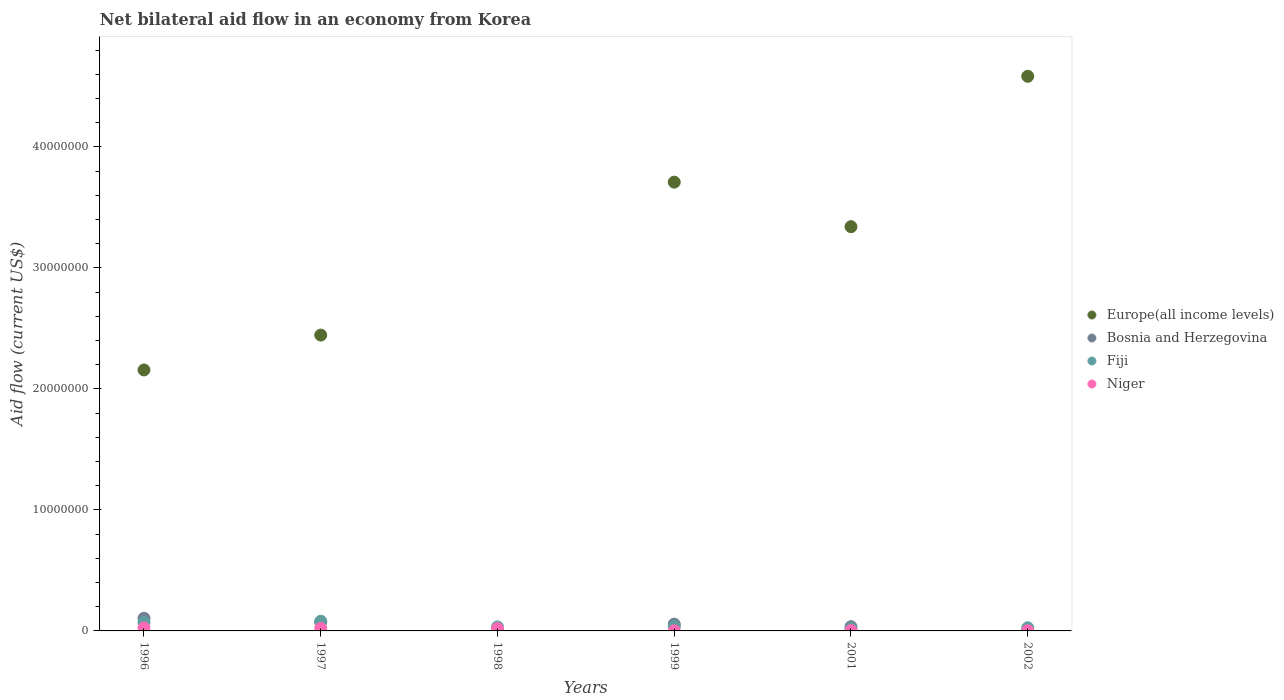What is the net bilateral aid flow in Fiji in 1998?
Provide a short and direct response. 3.30e+05. Across all years, what is the minimum net bilateral aid flow in Bosnia and Herzegovina?
Ensure brevity in your answer.  10000. What is the total net bilateral aid flow in Europe(all income levels) in the graph?
Provide a succinct answer. 1.62e+08. What is the difference between the net bilateral aid flow in Niger in 1998 and the net bilateral aid flow in Bosnia and Herzegovina in 2001?
Offer a terse response. -1.60e+05. In the year 1996, what is the difference between the net bilateral aid flow in Europe(all income levels) and net bilateral aid flow in Bosnia and Herzegovina?
Your answer should be compact. 2.05e+07. What is the ratio of the net bilateral aid flow in Niger in 1996 to that in 1999?
Keep it short and to the point. 24. What is the difference between the highest and the second highest net bilateral aid flow in Europe(all income levels)?
Ensure brevity in your answer.  8.75e+06. What is the difference between the highest and the lowest net bilateral aid flow in Bosnia and Herzegovina?
Offer a terse response. 1.03e+06. Does the net bilateral aid flow in Bosnia and Herzegovina monotonically increase over the years?
Your answer should be compact. No. Is the net bilateral aid flow in Europe(all income levels) strictly less than the net bilateral aid flow in Fiji over the years?
Your answer should be very brief. No. How many years are there in the graph?
Your response must be concise. 6. Where does the legend appear in the graph?
Your answer should be very brief. Center right. How many legend labels are there?
Provide a succinct answer. 4. What is the title of the graph?
Offer a terse response. Net bilateral aid flow in an economy from Korea. What is the label or title of the X-axis?
Give a very brief answer. Years. What is the Aid flow (current US$) of Europe(all income levels) in 1996?
Offer a terse response. 2.16e+07. What is the Aid flow (current US$) in Bosnia and Herzegovina in 1996?
Offer a terse response. 1.04e+06. What is the Aid flow (current US$) of Fiji in 1996?
Offer a terse response. 7.10e+05. What is the Aid flow (current US$) in Niger in 1996?
Make the answer very short. 2.40e+05. What is the Aid flow (current US$) of Europe(all income levels) in 1997?
Keep it short and to the point. 2.44e+07. What is the Aid flow (current US$) of Bosnia and Herzegovina in 1997?
Your response must be concise. 7.20e+05. What is the Aid flow (current US$) in Europe(all income levels) in 1999?
Offer a terse response. 3.71e+07. What is the Aid flow (current US$) of Bosnia and Herzegovina in 1999?
Your response must be concise. 5.60e+05. What is the Aid flow (current US$) in Europe(all income levels) in 2001?
Provide a succinct answer. 3.34e+07. What is the Aid flow (current US$) of Bosnia and Herzegovina in 2001?
Your response must be concise. 3.50e+05. What is the Aid flow (current US$) of Europe(all income levels) in 2002?
Ensure brevity in your answer.  4.58e+07. What is the Aid flow (current US$) in Fiji in 2002?
Offer a terse response. 2.60e+05. Across all years, what is the maximum Aid flow (current US$) of Europe(all income levels)?
Your answer should be compact. 4.58e+07. Across all years, what is the maximum Aid flow (current US$) in Bosnia and Herzegovina?
Provide a short and direct response. 1.04e+06. Across all years, what is the minimum Aid flow (current US$) of Europe(all income levels)?
Make the answer very short. 0. Across all years, what is the minimum Aid flow (current US$) in Bosnia and Herzegovina?
Keep it short and to the point. 10000. Across all years, what is the minimum Aid flow (current US$) in Fiji?
Give a very brief answer. 1.80e+05. What is the total Aid flow (current US$) in Europe(all income levels) in the graph?
Ensure brevity in your answer.  1.62e+08. What is the total Aid flow (current US$) of Bosnia and Herzegovina in the graph?
Provide a short and direct response. 2.70e+06. What is the total Aid flow (current US$) in Fiji in the graph?
Give a very brief answer. 2.63e+06. What is the total Aid flow (current US$) of Niger in the graph?
Your answer should be very brief. 7.00e+05. What is the difference between the Aid flow (current US$) of Europe(all income levels) in 1996 and that in 1997?
Offer a terse response. -2.88e+06. What is the difference between the Aid flow (current US$) in Bosnia and Herzegovina in 1996 and that in 1997?
Make the answer very short. 3.20e+05. What is the difference between the Aid flow (current US$) of Fiji in 1996 and that in 1997?
Give a very brief answer. -9.00e+04. What is the difference between the Aid flow (current US$) in Bosnia and Herzegovina in 1996 and that in 1998?
Make the answer very short. 1.03e+06. What is the difference between the Aid flow (current US$) of Niger in 1996 and that in 1998?
Your response must be concise. 5.00e+04. What is the difference between the Aid flow (current US$) of Europe(all income levels) in 1996 and that in 1999?
Your response must be concise. -1.55e+07. What is the difference between the Aid flow (current US$) in Niger in 1996 and that in 1999?
Offer a terse response. 2.30e+05. What is the difference between the Aid flow (current US$) in Europe(all income levels) in 1996 and that in 2001?
Keep it short and to the point. -1.18e+07. What is the difference between the Aid flow (current US$) in Bosnia and Herzegovina in 1996 and that in 2001?
Offer a terse response. 6.90e+05. What is the difference between the Aid flow (current US$) in Fiji in 1996 and that in 2001?
Keep it short and to the point. 5.30e+05. What is the difference between the Aid flow (current US$) of Niger in 1996 and that in 2001?
Your answer should be compact. 2.10e+05. What is the difference between the Aid flow (current US$) of Europe(all income levels) in 1996 and that in 2002?
Your answer should be very brief. -2.43e+07. What is the difference between the Aid flow (current US$) in Bosnia and Herzegovina in 1996 and that in 2002?
Provide a short and direct response. 1.02e+06. What is the difference between the Aid flow (current US$) of Fiji in 1996 and that in 2002?
Keep it short and to the point. 4.50e+05. What is the difference between the Aid flow (current US$) of Niger in 1996 and that in 2002?
Offer a very short reply. 2.20e+05. What is the difference between the Aid flow (current US$) of Bosnia and Herzegovina in 1997 and that in 1998?
Keep it short and to the point. 7.10e+05. What is the difference between the Aid flow (current US$) in Europe(all income levels) in 1997 and that in 1999?
Your response must be concise. -1.26e+07. What is the difference between the Aid flow (current US$) of Bosnia and Herzegovina in 1997 and that in 1999?
Offer a very short reply. 1.60e+05. What is the difference between the Aid flow (current US$) in Fiji in 1997 and that in 1999?
Your answer should be very brief. 4.50e+05. What is the difference between the Aid flow (current US$) of Europe(all income levels) in 1997 and that in 2001?
Provide a short and direct response. -8.96e+06. What is the difference between the Aid flow (current US$) of Bosnia and Herzegovina in 1997 and that in 2001?
Offer a very short reply. 3.70e+05. What is the difference between the Aid flow (current US$) in Fiji in 1997 and that in 2001?
Keep it short and to the point. 6.20e+05. What is the difference between the Aid flow (current US$) in Europe(all income levels) in 1997 and that in 2002?
Your response must be concise. -2.14e+07. What is the difference between the Aid flow (current US$) of Bosnia and Herzegovina in 1997 and that in 2002?
Your response must be concise. 7.00e+05. What is the difference between the Aid flow (current US$) of Fiji in 1997 and that in 2002?
Provide a succinct answer. 5.40e+05. What is the difference between the Aid flow (current US$) in Bosnia and Herzegovina in 1998 and that in 1999?
Give a very brief answer. -5.50e+05. What is the difference between the Aid flow (current US$) of Niger in 1998 and that in 1999?
Make the answer very short. 1.80e+05. What is the difference between the Aid flow (current US$) of Fiji in 1998 and that in 2001?
Provide a short and direct response. 1.50e+05. What is the difference between the Aid flow (current US$) in Europe(all income levels) in 1999 and that in 2001?
Keep it short and to the point. 3.68e+06. What is the difference between the Aid flow (current US$) of Fiji in 1999 and that in 2001?
Offer a terse response. 1.70e+05. What is the difference between the Aid flow (current US$) in Niger in 1999 and that in 2001?
Your answer should be very brief. -2.00e+04. What is the difference between the Aid flow (current US$) in Europe(all income levels) in 1999 and that in 2002?
Give a very brief answer. -8.75e+06. What is the difference between the Aid flow (current US$) in Bosnia and Herzegovina in 1999 and that in 2002?
Offer a terse response. 5.40e+05. What is the difference between the Aid flow (current US$) of Fiji in 1999 and that in 2002?
Your answer should be compact. 9.00e+04. What is the difference between the Aid flow (current US$) of Niger in 1999 and that in 2002?
Ensure brevity in your answer.  -10000. What is the difference between the Aid flow (current US$) in Europe(all income levels) in 2001 and that in 2002?
Provide a succinct answer. -1.24e+07. What is the difference between the Aid flow (current US$) of Niger in 2001 and that in 2002?
Your answer should be very brief. 10000. What is the difference between the Aid flow (current US$) in Europe(all income levels) in 1996 and the Aid flow (current US$) in Bosnia and Herzegovina in 1997?
Give a very brief answer. 2.08e+07. What is the difference between the Aid flow (current US$) of Europe(all income levels) in 1996 and the Aid flow (current US$) of Fiji in 1997?
Provide a succinct answer. 2.08e+07. What is the difference between the Aid flow (current US$) in Europe(all income levels) in 1996 and the Aid flow (current US$) in Niger in 1997?
Keep it short and to the point. 2.14e+07. What is the difference between the Aid flow (current US$) in Bosnia and Herzegovina in 1996 and the Aid flow (current US$) in Fiji in 1997?
Your answer should be very brief. 2.40e+05. What is the difference between the Aid flow (current US$) of Bosnia and Herzegovina in 1996 and the Aid flow (current US$) of Niger in 1997?
Make the answer very short. 8.30e+05. What is the difference between the Aid flow (current US$) of Fiji in 1996 and the Aid flow (current US$) of Niger in 1997?
Offer a very short reply. 5.00e+05. What is the difference between the Aid flow (current US$) of Europe(all income levels) in 1996 and the Aid flow (current US$) of Bosnia and Herzegovina in 1998?
Your answer should be very brief. 2.16e+07. What is the difference between the Aid flow (current US$) of Europe(all income levels) in 1996 and the Aid flow (current US$) of Fiji in 1998?
Offer a very short reply. 2.12e+07. What is the difference between the Aid flow (current US$) of Europe(all income levels) in 1996 and the Aid flow (current US$) of Niger in 1998?
Keep it short and to the point. 2.14e+07. What is the difference between the Aid flow (current US$) of Bosnia and Herzegovina in 1996 and the Aid flow (current US$) of Fiji in 1998?
Make the answer very short. 7.10e+05. What is the difference between the Aid flow (current US$) in Bosnia and Herzegovina in 1996 and the Aid flow (current US$) in Niger in 1998?
Give a very brief answer. 8.50e+05. What is the difference between the Aid flow (current US$) of Fiji in 1996 and the Aid flow (current US$) of Niger in 1998?
Your response must be concise. 5.20e+05. What is the difference between the Aid flow (current US$) in Europe(all income levels) in 1996 and the Aid flow (current US$) in Bosnia and Herzegovina in 1999?
Give a very brief answer. 2.10e+07. What is the difference between the Aid flow (current US$) in Europe(all income levels) in 1996 and the Aid flow (current US$) in Fiji in 1999?
Offer a very short reply. 2.12e+07. What is the difference between the Aid flow (current US$) in Europe(all income levels) in 1996 and the Aid flow (current US$) in Niger in 1999?
Your answer should be compact. 2.16e+07. What is the difference between the Aid flow (current US$) of Bosnia and Herzegovina in 1996 and the Aid flow (current US$) of Fiji in 1999?
Your answer should be very brief. 6.90e+05. What is the difference between the Aid flow (current US$) of Bosnia and Herzegovina in 1996 and the Aid flow (current US$) of Niger in 1999?
Offer a terse response. 1.03e+06. What is the difference between the Aid flow (current US$) in Europe(all income levels) in 1996 and the Aid flow (current US$) in Bosnia and Herzegovina in 2001?
Offer a very short reply. 2.12e+07. What is the difference between the Aid flow (current US$) in Europe(all income levels) in 1996 and the Aid flow (current US$) in Fiji in 2001?
Your answer should be very brief. 2.14e+07. What is the difference between the Aid flow (current US$) of Europe(all income levels) in 1996 and the Aid flow (current US$) of Niger in 2001?
Offer a terse response. 2.15e+07. What is the difference between the Aid flow (current US$) in Bosnia and Herzegovina in 1996 and the Aid flow (current US$) in Fiji in 2001?
Your answer should be very brief. 8.60e+05. What is the difference between the Aid flow (current US$) of Bosnia and Herzegovina in 1996 and the Aid flow (current US$) of Niger in 2001?
Offer a very short reply. 1.01e+06. What is the difference between the Aid flow (current US$) in Fiji in 1996 and the Aid flow (current US$) in Niger in 2001?
Make the answer very short. 6.80e+05. What is the difference between the Aid flow (current US$) of Europe(all income levels) in 1996 and the Aid flow (current US$) of Bosnia and Herzegovina in 2002?
Ensure brevity in your answer.  2.16e+07. What is the difference between the Aid flow (current US$) of Europe(all income levels) in 1996 and the Aid flow (current US$) of Fiji in 2002?
Your response must be concise. 2.13e+07. What is the difference between the Aid flow (current US$) of Europe(all income levels) in 1996 and the Aid flow (current US$) of Niger in 2002?
Offer a terse response. 2.16e+07. What is the difference between the Aid flow (current US$) in Bosnia and Herzegovina in 1996 and the Aid flow (current US$) in Fiji in 2002?
Your response must be concise. 7.80e+05. What is the difference between the Aid flow (current US$) in Bosnia and Herzegovina in 1996 and the Aid flow (current US$) in Niger in 2002?
Your answer should be very brief. 1.02e+06. What is the difference between the Aid flow (current US$) of Fiji in 1996 and the Aid flow (current US$) of Niger in 2002?
Provide a short and direct response. 6.90e+05. What is the difference between the Aid flow (current US$) in Europe(all income levels) in 1997 and the Aid flow (current US$) in Bosnia and Herzegovina in 1998?
Make the answer very short. 2.44e+07. What is the difference between the Aid flow (current US$) of Europe(all income levels) in 1997 and the Aid flow (current US$) of Fiji in 1998?
Make the answer very short. 2.41e+07. What is the difference between the Aid flow (current US$) of Europe(all income levels) in 1997 and the Aid flow (current US$) of Niger in 1998?
Offer a terse response. 2.43e+07. What is the difference between the Aid flow (current US$) of Bosnia and Herzegovina in 1997 and the Aid flow (current US$) of Fiji in 1998?
Ensure brevity in your answer.  3.90e+05. What is the difference between the Aid flow (current US$) of Bosnia and Herzegovina in 1997 and the Aid flow (current US$) of Niger in 1998?
Offer a terse response. 5.30e+05. What is the difference between the Aid flow (current US$) of Europe(all income levels) in 1997 and the Aid flow (current US$) of Bosnia and Herzegovina in 1999?
Offer a terse response. 2.39e+07. What is the difference between the Aid flow (current US$) in Europe(all income levels) in 1997 and the Aid flow (current US$) in Fiji in 1999?
Offer a very short reply. 2.41e+07. What is the difference between the Aid flow (current US$) of Europe(all income levels) in 1997 and the Aid flow (current US$) of Niger in 1999?
Your response must be concise. 2.44e+07. What is the difference between the Aid flow (current US$) in Bosnia and Herzegovina in 1997 and the Aid flow (current US$) in Niger in 1999?
Offer a terse response. 7.10e+05. What is the difference between the Aid flow (current US$) in Fiji in 1997 and the Aid flow (current US$) in Niger in 1999?
Make the answer very short. 7.90e+05. What is the difference between the Aid flow (current US$) of Europe(all income levels) in 1997 and the Aid flow (current US$) of Bosnia and Herzegovina in 2001?
Your response must be concise. 2.41e+07. What is the difference between the Aid flow (current US$) in Europe(all income levels) in 1997 and the Aid flow (current US$) in Fiji in 2001?
Offer a terse response. 2.43e+07. What is the difference between the Aid flow (current US$) of Europe(all income levels) in 1997 and the Aid flow (current US$) of Niger in 2001?
Your answer should be compact. 2.44e+07. What is the difference between the Aid flow (current US$) of Bosnia and Herzegovina in 1997 and the Aid flow (current US$) of Fiji in 2001?
Your answer should be compact. 5.40e+05. What is the difference between the Aid flow (current US$) in Bosnia and Herzegovina in 1997 and the Aid flow (current US$) in Niger in 2001?
Provide a succinct answer. 6.90e+05. What is the difference between the Aid flow (current US$) of Fiji in 1997 and the Aid flow (current US$) of Niger in 2001?
Offer a very short reply. 7.70e+05. What is the difference between the Aid flow (current US$) of Europe(all income levels) in 1997 and the Aid flow (current US$) of Bosnia and Herzegovina in 2002?
Give a very brief answer. 2.44e+07. What is the difference between the Aid flow (current US$) of Europe(all income levels) in 1997 and the Aid flow (current US$) of Fiji in 2002?
Offer a very short reply. 2.42e+07. What is the difference between the Aid flow (current US$) in Europe(all income levels) in 1997 and the Aid flow (current US$) in Niger in 2002?
Make the answer very short. 2.44e+07. What is the difference between the Aid flow (current US$) in Bosnia and Herzegovina in 1997 and the Aid flow (current US$) in Fiji in 2002?
Make the answer very short. 4.60e+05. What is the difference between the Aid flow (current US$) of Bosnia and Herzegovina in 1997 and the Aid flow (current US$) of Niger in 2002?
Ensure brevity in your answer.  7.00e+05. What is the difference between the Aid flow (current US$) in Fiji in 1997 and the Aid flow (current US$) in Niger in 2002?
Keep it short and to the point. 7.80e+05. What is the difference between the Aid flow (current US$) in Bosnia and Herzegovina in 1998 and the Aid flow (current US$) in Niger in 1999?
Offer a terse response. 0. What is the difference between the Aid flow (current US$) of Bosnia and Herzegovina in 1998 and the Aid flow (current US$) of Niger in 2001?
Keep it short and to the point. -2.00e+04. What is the difference between the Aid flow (current US$) of Fiji in 1998 and the Aid flow (current US$) of Niger in 2001?
Ensure brevity in your answer.  3.00e+05. What is the difference between the Aid flow (current US$) of Bosnia and Herzegovina in 1998 and the Aid flow (current US$) of Niger in 2002?
Give a very brief answer. -10000. What is the difference between the Aid flow (current US$) in Europe(all income levels) in 1999 and the Aid flow (current US$) in Bosnia and Herzegovina in 2001?
Offer a very short reply. 3.67e+07. What is the difference between the Aid flow (current US$) in Europe(all income levels) in 1999 and the Aid flow (current US$) in Fiji in 2001?
Your answer should be compact. 3.69e+07. What is the difference between the Aid flow (current US$) of Europe(all income levels) in 1999 and the Aid flow (current US$) of Niger in 2001?
Provide a succinct answer. 3.71e+07. What is the difference between the Aid flow (current US$) of Bosnia and Herzegovina in 1999 and the Aid flow (current US$) of Niger in 2001?
Keep it short and to the point. 5.30e+05. What is the difference between the Aid flow (current US$) in Europe(all income levels) in 1999 and the Aid flow (current US$) in Bosnia and Herzegovina in 2002?
Offer a terse response. 3.71e+07. What is the difference between the Aid flow (current US$) in Europe(all income levels) in 1999 and the Aid flow (current US$) in Fiji in 2002?
Offer a terse response. 3.68e+07. What is the difference between the Aid flow (current US$) in Europe(all income levels) in 1999 and the Aid flow (current US$) in Niger in 2002?
Ensure brevity in your answer.  3.71e+07. What is the difference between the Aid flow (current US$) of Bosnia and Herzegovina in 1999 and the Aid flow (current US$) of Niger in 2002?
Provide a short and direct response. 5.40e+05. What is the difference between the Aid flow (current US$) of Europe(all income levels) in 2001 and the Aid flow (current US$) of Bosnia and Herzegovina in 2002?
Give a very brief answer. 3.34e+07. What is the difference between the Aid flow (current US$) of Europe(all income levels) in 2001 and the Aid flow (current US$) of Fiji in 2002?
Your answer should be compact. 3.32e+07. What is the difference between the Aid flow (current US$) of Europe(all income levels) in 2001 and the Aid flow (current US$) of Niger in 2002?
Keep it short and to the point. 3.34e+07. What is the difference between the Aid flow (current US$) in Bosnia and Herzegovina in 2001 and the Aid flow (current US$) in Niger in 2002?
Your answer should be compact. 3.30e+05. What is the average Aid flow (current US$) in Europe(all income levels) per year?
Offer a very short reply. 2.71e+07. What is the average Aid flow (current US$) in Bosnia and Herzegovina per year?
Offer a very short reply. 4.50e+05. What is the average Aid flow (current US$) of Fiji per year?
Offer a terse response. 4.38e+05. What is the average Aid flow (current US$) in Niger per year?
Offer a terse response. 1.17e+05. In the year 1996, what is the difference between the Aid flow (current US$) in Europe(all income levels) and Aid flow (current US$) in Bosnia and Herzegovina?
Provide a short and direct response. 2.05e+07. In the year 1996, what is the difference between the Aid flow (current US$) of Europe(all income levels) and Aid flow (current US$) of Fiji?
Your answer should be very brief. 2.09e+07. In the year 1996, what is the difference between the Aid flow (current US$) in Europe(all income levels) and Aid flow (current US$) in Niger?
Keep it short and to the point. 2.13e+07. In the year 1996, what is the difference between the Aid flow (current US$) of Bosnia and Herzegovina and Aid flow (current US$) of Fiji?
Make the answer very short. 3.30e+05. In the year 1996, what is the difference between the Aid flow (current US$) of Bosnia and Herzegovina and Aid flow (current US$) of Niger?
Ensure brevity in your answer.  8.00e+05. In the year 1997, what is the difference between the Aid flow (current US$) of Europe(all income levels) and Aid flow (current US$) of Bosnia and Herzegovina?
Offer a terse response. 2.37e+07. In the year 1997, what is the difference between the Aid flow (current US$) in Europe(all income levels) and Aid flow (current US$) in Fiji?
Offer a very short reply. 2.36e+07. In the year 1997, what is the difference between the Aid flow (current US$) in Europe(all income levels) and Aid flow (current US$) in Niger?
Make the answer very short. 2.42e+07. In the year 1997, what is the difference between the Aid flow (current US$) of Bosnia and Herzegovina and Aid flow (current US$) of Fiji?
Your response must be concise. -8.00e+04. In the year 1997, what is the difference between the Aid flow (current US$) of Bosnia and Herzegovina and Aid flow (current US$) of Niger?
Offer a very short reply. 5.10e+05. In the year 1997, what is the difference between the Aid flow (current US$) in Fiji and Aid flow (current US$) in Niger?
Give a very brief answer. 5.90e+05. In the year 1998, what is the difference between the Aid flow (current US$) in Bosnia and Herzegovina and Aid flow (current US$) in Fiji?
Make the answer very short. -3.20e+05. In the year 1998, what is the difference between the Aid flow (current US$) of Fiji and Aid flow (current US$) of Niger?
Give a very brief answer. 1.40e+05. In the year 1999, what is the difference between the Aid flow (current US$) of Europe(all income levels) and Aid flow (current US$) of Bosnia and Herzegovina?
Your answer should be compact. 3.65e+07. In the year 1999, what is the difference between the Aid flow (current US$) in Europe(all income levels) and Aid flow (current US$) in Fiji?
Keep it short and to the point. 3.67e+07. In the year 1999, what is the difference between the Aid flow (current US$) in Europe(all income levels) and Aid flow (current US$) in Niger?
Your response must be concise. 3.71e+07. In the year 1999, what is the difference between the Aid flow (current US$) of Bosnia and Herzegovina and Aid flow (current US$) of Fiji?
Provide a succinct answer. 2.10e+05. In the year 1999, what is the difference between the Aid flow (current US$) of Fiji and Aid flow (current US$) of Niger?
Ensure brevity in your answer.  3.40e+05. In the year 2001, what is the difference between the Aid flow (current US$) of Europe(all income levels) and Aid flow (current US$) of Bosnia and Herzegovina?
Keep it short and to the point. 3.31e+07. In the year 2001, what is the difference between the Aid flow (current US$) of Europe(all income levels) and Aid flow (current US$) of Fiji?
Your answer should be very brief. 3.32e+07. In the year 2001, what is the difference between the Aid flow (current US$) of Europe(all income levels) and Aid flow (current US$) of Niger?
Keep it short and to the point. 3.34e+07. In the year 2001, what is the difference between the Aid flow (current US$) of Bosnia and Herzegovina and Aid flow (current US$) of Fiji?
Give a very brief answer. 1.70e+05. In the year 2001, what is the difference between the Aid flow (current US$) in Fiji and Aid flow (current US$) in Niger?
Give a very brief answer. 1.50e+05. In the year 2002, what is the difference between the Aid flow (current US$) of Europe(all income levels) and Aid flow (current US$) of Bosnia and Herzegovina?
Keep it short and to the point. 4.58e+07. In the year 2002, what is the difference between the Aid flow (current US$) of Europe(all income levels) and Aid flow (current US$) of Fiji?
Your answer should be very brief. 4.56e+07. In the year 2002, what is the difference between the Aid flow (current US$) in Europe(all income levels) and Aid flow (current US$) in Niger?
Offer a very short reply. 4.58e+07. In the year 2002, what is the difference between the Aid flow (current US$) in Bosnia and Herzegovina and Aid flow (current US$) in Fiji?
Offer a terse response. -2.40e+05. In the year 2002, what is the difference between the Aid flow (current US$) in Fiji and Aid flow (current US$) in Niger?
Provide a short and direct response. 2.40e+05. What is the ratio of the Aid flow (current US$) in Europe(all income levels) in 1996 to that in 1997?
Your answer should be compact. 0.88. What is the ratio of the Aid flow (current US$) in Bosnia and Herzegovina in 1996 to that in 1997?
Give a very brief answer. 1.44. What is the ratio of the Aid flow (current US$) of Fiji in 1996 to that in 1997?
Provide a short and direct response. 0.89. What is the ratio of the Aid flow (current US$) in Bosnia and Herzegovina in 1996 to that in 1998?
Your response must be concise. 104. What is the ratio of the Aid flow (current US$) of Fiji in 1996 to that in 1998?
Ensure brevity in your answer.  2.15. What is the ratio of the Aid flow (current US$) of Niger in 1996 to that in 1998?
Ensure brevity in your answer.  1.26. What is the ratio of the Aid flow (current US$) of Europe(all income levels) in 1996 to that in 1999?
Make the answer very short. 0.58. What is the ratio of the Aid flow (current US$) in Bosnia and Herzegovina in 1996 to that in 1999?
Offer a very short reply. 1.86. What is the ratio of the Aid flow (current US$) of Fiji in 1996 to that in 1999?
Offer a terse response. 2.03. What is the ratio of the Aid flow (current US$) of Europe(all income levels) in 1996 to that in 2001?
Keep it short and to the point. 0.65. What is the ratio of the Aid flow (current US$) in Bosnia and Herzegovina in 1996 to that in 2001?
Give a very brief answer. 2.97. What is the ratio of the Aid flow (current US$) of Fiji in 1996 to that in 2001?
Your answer should be very brief. 3.94. What is the ratio of the Aid flow (current US$) in Europe(all income levels) in 1996 to that in 2002?
Provide a short and direct response. 0.47. What is the ratio of the Aid flow (current US$) in Fiji in 1996 to that in 2002?
Ensure brevity in your answer.  2.73. What is the ratio of the Aid flow (current US$) of Bosnia and Herzegovina in 1997 to that in 1998?
Your answer should be compact. 72. What is the ratio of the Aid flow (current US$) in Fiji in 1997 to that in 1998?
Keep it short and to the point. 2.42. What is the ratio of the Aid flow (current US$) in Niger in 1997 to that in 1998?
Make the answer very short. 1.11. What is the ratio of the Aid flow (current US$) of Europe(all income levels) in 1997 to that in 1999?
Offer a terse response. 0.66. What is the ratio of the Aid flow (current US$) in Fiji in 1997 to that in 1999?
Ensure brevity in your answer.  2.29. What is the ratio of the Aid flow (current US$) in Niger in 1997 to that in 1999?
Provide a succinct answer. 21. What is the ratio of the Aid flow (current US$) of Europe(all income levels) in 1997 to that in 2001?
Provide a short and direct response. 0.73. What is the ratio of the Aid flow (current US$) in Bosnia and Herzegovina in 1997 to that in 2001?
Provide a succinct answer. 2.06. What is the ratio of the Aid flow (current US$) in Fiji in 1997 to that in 2001?
Keep it short and to the point. 4.44. What is the ratio of the Aid flow (current US$) of Europe(all income levels) in 1997 to that in 2002?
Ensure brevity in your answer.  0.53. What is the ratio of the Aid flow (current US$) of Fiji in 1997 to that in 2002?
Offer a terse response. 3.08. What is the ratio of the Aid flow (current US$) in Niger in 1997 to that in 2002?
Give a very brief answer. 10.5. What is the ratio of the Aid flow (current US$) of Bosnia and Herzegovina in 1998 to that in 1999?
Give a very brief answer. 0.02. What is the ratio of the Aid flow (current US$) of Fiji in 1998 to that in 1999?
Provide a succinct answer. 0.94. What is the ratio of the Aid flow (current US$) of Niger in 1998 to that in 1999?
Your answer should be compact. 19. What is the ratio of the Aid flow (current US$) of Bosnia and Herzegovina in 1998 to that in 2001?
Make the answer very short. 0.03. What is the ratio of the Aid flow (current US$) in Fiji in 1998 to that in 2001?
Offer a very short reply. 1.83. What is the ratio of the Aid flow (current US$) in Niger in 1998 to that in 2001?
Offer a very short reply. 6.33. What is the ratio of the Aid flow (current US$) in Fiji in 1998 to that in 2002?
Make the answer very short. 1.27. What is the ratio of the Aid flow (current US$) of Niger in 1998 to that in 2002?
Offer a very short reply. 9.5. What is the ratio of the Aid flow (current US$) in Europe(all income levels) in 1999 to that in 2001?
Your response must be concise. 1.11. What is the ratio of the Aid flow (current US$) of Bosnia and Herzegovina in 1999 to that in 2001?
Make the answer very short. 1.6. What is the ratio of the Aid flow (current US$) in Fiji in 1999 to that in 2001?
Keep it short and to the point. 1.94. What is the ratio of the Aid flow (current US$) in Niger in 1999 to that in 2001?
Offer a terse response. 0.33. What is the ratio of the Aid flow (current US$) in Europe(all income levels) in 1999 to that in 2002?
Ensure brevity in your answer.  0.81. What is the ratio of the Aid flow (current US$) of Fiji in 1999 to that in 2002?
Your answer should be compact. 1.35. What is the ratio of the Aid flow (current US$) of Niger in 1999 to that in 2002?
Provide a short and direct response. 0.5. What is the ratio of the Aid flow (current US$) in Europe(all income levels) in 2001 to that in 2002?
Keep it short and to the point. 0.73. What is the ratio of the Aid flow (current US$) of Fiji in 2001 to that in 2002?
Ensure brevity in your answer.  0.69. What is the difference between the highest and the second highest Aid flow (current US$) of Europe(all income levels)?
Offer a terse response. 8.75e+06. What is the difference between the highest and the second highest Aid flow (current US$) of Bosnia and Herzegovina?
Your answer should be very brief. 3.20e+05. What is the difference between the highest and the second highest Aid flow (current US$) in Fiji?
Your answer should be compact. 9.00e+04. What is the difference between the highest and the lowest Aid flow (current US$) of Europe(all income levels)?
Your answer should be very brief. 4.58e+07. What is the difference between the highest and the lowest Aid flow (current US$) of Bosnia and Herzegovina?
Offer a terse response. 1.03e+06. What is the difference between the highest and the lowest Aid flow (current US$) of Fiji?
Your answer should be very brief. 6.20e+05. What is the difference between the highest and the lowest Aid flow (current US$) of Niger?
Provide a succinct answer. 2.30e+05. 